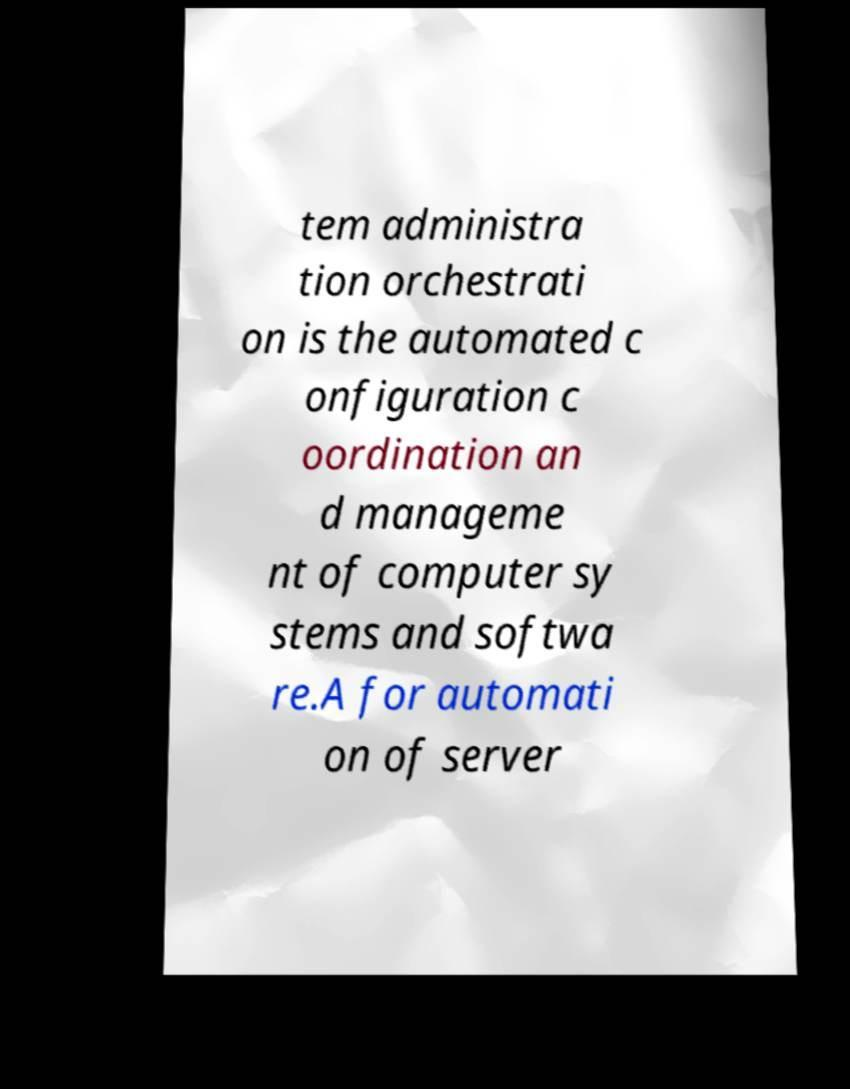Can you accurately transcribe the text from the provided image for me? tem administra tion orchestrati on is the automated c onfiguration c oordination an d manageme nt of computer sy stems and softwa re.A for automati on of server 